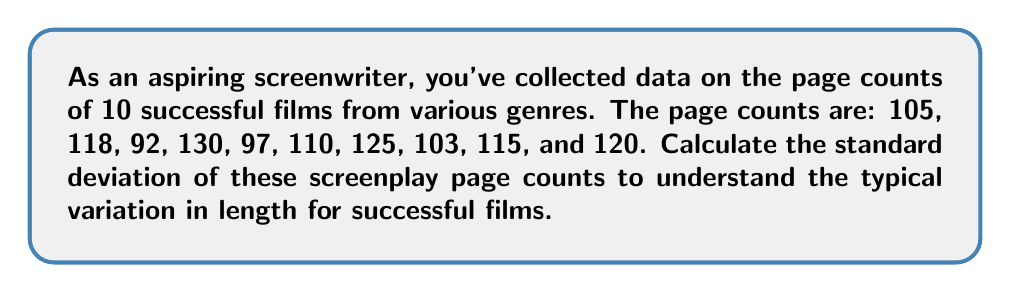Give your solution to this math problem. To calculate the standard deviation, we'll follow these steps:

1. Calculate the mean (average) page count:
   $$\bar{x} = \frac{105 + 118 + 92 + 130 + 97 + 110 + 125 + 103 + 115 + 120}{10} = 111.5$$

2. Calculate the squared differences from the mean:
   $$(105 - 111.5)^2 = (-6.5)^2 = 42.25$$
   $$(118 - 111.5)^2 = (6.5)^2 = 42.25$$
   $$(92 - 111.5)^2 = (-19.5)^2 = 380.25$$
   $$(130 - 111.5)^2 = (18.5)^2 = 342.25$$
   $$(97 - 111.5)^2 = (-14.5)^2 = 210.25$$
   $$(110 - 111.5)^2 = (-1.5)^2 = 2.25$$
   $$(125 - 111.5)^2 = (13.5)^2 = 182.25$$
   $$(103 - 111.5)^2 = (-8.5)^2 = 72.25$$
   $$(115 - 111.5)^2 = (3.5)^2 = 12.25$$
   $$(120 - 111.5)^2 = (8.5)^2 = 72.25$$

3. Sum the squared differences:
   $$\sum (x_i - \bar{x})^2 = 42.25 + 42.25 + 380.25 + 342.25 + 210.25 + 2.25 + 182.25 + 72.25 + 12.25 + 72.25 = 1358.5$$

4. Divide by (n-1) to get the variance:
   $$s^2 = \frac{\sum (x_i - \bar{x})^2}{n-1} = \frac{1358.5}{9} = 150.94444...$$

5. Take the square root to get the standard deviation:
   $$s = \sqrt{150.94444...} = 12.2860...$$
Answer: $12.29$ pages (rounded to two decimal places) 